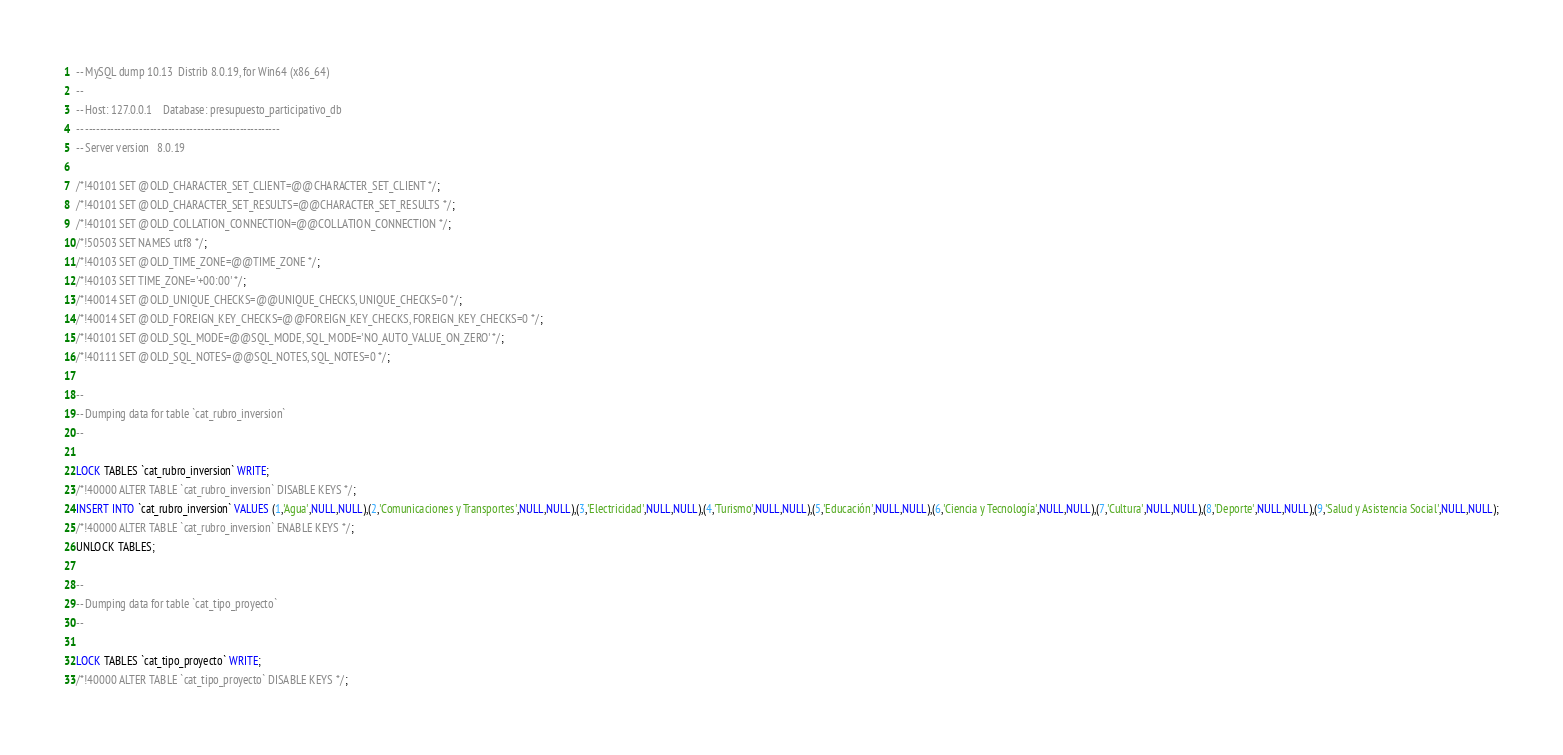<code> <loc_0><loc_0><loc_500><loc_500><_SQL_>-- MySQL dump 10.13  Distrib 8.0.19, for Win64 (x86_64)
--
-- Host: 127.0.0.1    Database: presupuesto_participativo_db
-- ------------------------------------------------------
-- Server version	8.0.19

/*!40101 SET @OLD_CHARACTER_SET_CLIENT=@@CHARACTER_SET_CLIENT */;
/*!40101 SET @OLD_CHARACTER_SET_RESULTS=@@CHARACTER_SET_RESULTS */;
/*!40101 SET @OLD_COLLATION_CONNECTION=@@COLLATION_CONNECTION */;
/*!50503 SET NAMES utf8 */;
/*!40103 SET @OLD_TIME_ZONE=@@TIME_ZONE */;
/*!40103 SET TIME_ZONE='+00:00' */;
/*!40014 SET @OLD_UNIQUE_CHECKS=@@UNIQUE_CHECKS, UNIQUE_CHECKS=0 */;
/*!40014 SET @OLD_FOREIGN_KEY_CHECKS=@@FOREIGN_KEY_CHECKS, FOREIGN_KEY_CHECKS=0 */;
/*!40101 SET @OLD_SQL_MODE=@@SQL_MODE, SQL_MODE='NO_AUTO_VALUE_ON_ZERO' */;
/*!40111 SET @OLD_SQL_NOTES=@@SQL_NOTES, SQL_NOTES=0 */;

--
-- Dumping data for table `cat_rubro_inversion`
--

LOCK TABLES `cat_rubro_inversion` WRITE;
/*!40000 ALTER TABLE `cat_rubro_inversion` DISABLE KEYS */;
INSERT INTO `cat_rubro_inversion` VALUES (1,'Agua',NULL,NULL),(2,'Comunicaciones y Transportes',NULL,NULL),(3,'Electricidad',NULL,NULL),(4,'Turismo',NULL,NULL),(5,'Educación',NULL,NULL),(6,'Ciencia y Tecnología',NULL,NULL),(7,'Cultura',NULL,NULL),(8,'Deporte',NULL,NULL),(9,'Salud y Asistencia Social',NULL,NULL);
/*!40000 ALTER TABLE `cat_rubro_inversion` ENABLE KEYS */;
UNLOCK TABLES;

--
-- Dumping data for table `cat_tipo_proyecto`
--

LOCK TABLES `cat_tipo_proyecto` WRITE;
/*!40000 ALTER TABLE `cat_tipo_proyecto` DISABLE KEYS */;</code> 